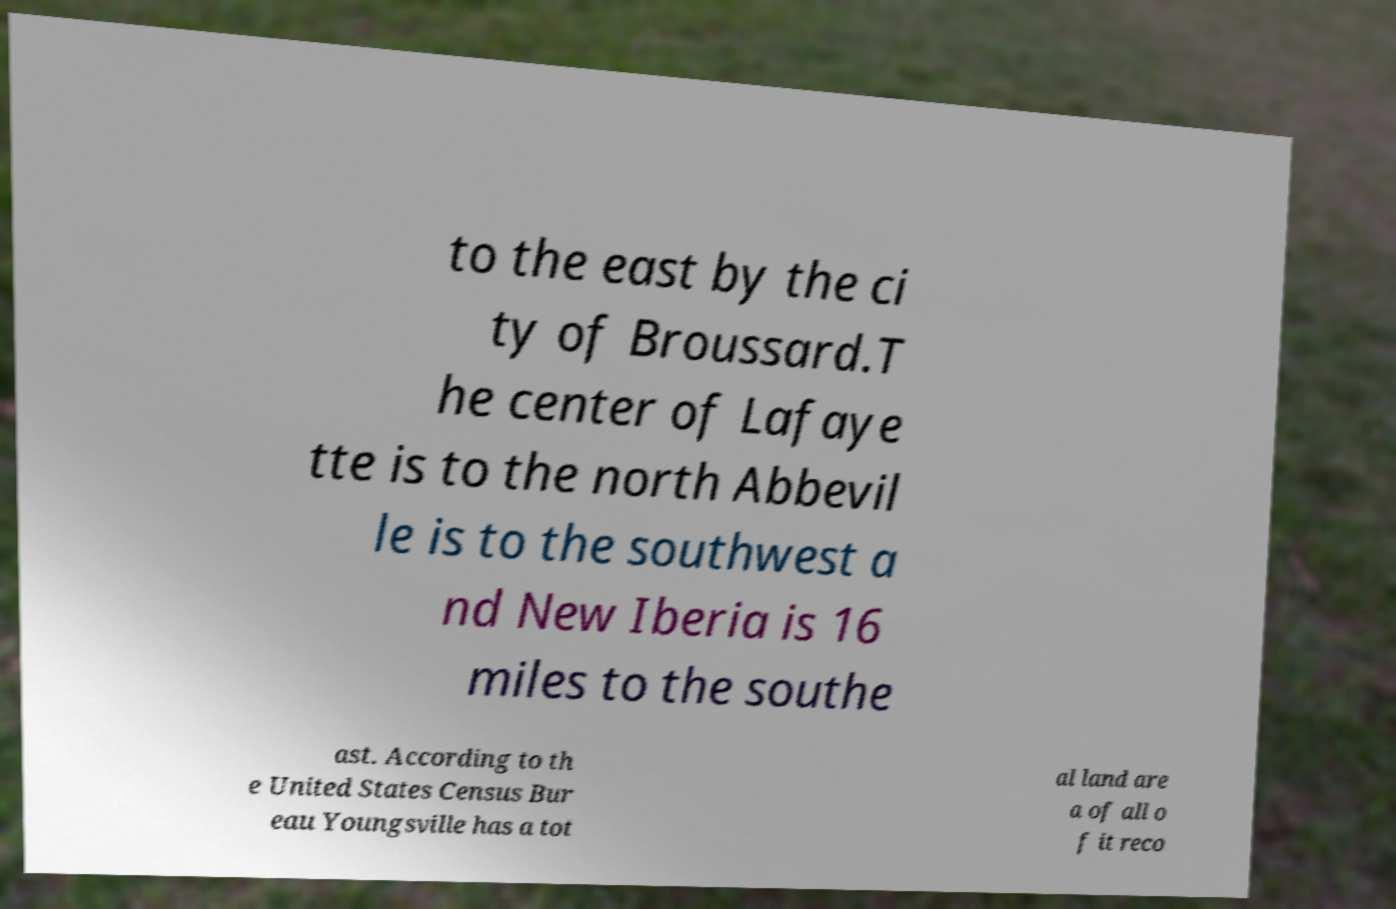What messages or text are displayed in this image? I need them in a readable, typed format. to the east by the ci ty of Broussard.T he center of Lafaye tte is to the north Abbevil le is to the southwest a nd New Iberia is 16 miles to the southe ast. According to th e United States Census Bur eau Youngsville has a tot al land are a of all o f it reco 